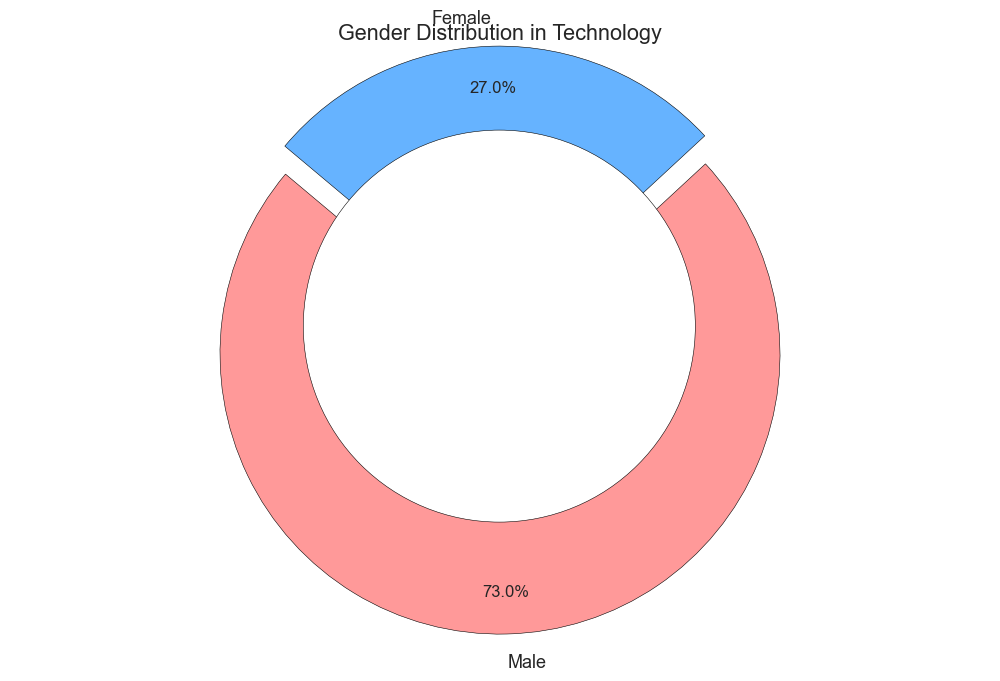What percentage of females are represented in Mathematics? The chart for Mathematics shows the distribution with clear labels for each gender. To find the percentage of females, refer to the labeled section for females.
Answer: 32% Which industry has the highest percentage of female representation? Look at all the pie charts and compare the labeled percentages for females across all industries to identify the highest value.
Answer: Science What is the combined percentage of males in both Engineering and Technology? Add the percentage of males in Engineering (85%) and Technology (73%).
Answer: 158% How much more percentage of males are there in Technology compared to females? Subtract the percentage of females in Technology (27%) from the percentage of males in Technology (73%).
Answer: 46% How does female representation in Science compare to that in Engineering? Compare the labeled female percentages in both Science (36%) and Engineering (15%).
Answer: Science has a higher female representation Which industry has the smallest gender gap? Calculate the gender gap for each industry by subtracting the female percentage from the male percentage and find the smallest value.
Answer: Science What is the difference in female representation between Science and Mathematics? Subtract the female percentage in Mathematics (32%) from the female percentage in Science (36%).
Answer: 4% If we were to average the percentage of female representation across all industries, what would it be? Add the percentage of females in each industry (27% in Technology, 15% in Engineering, 36% in Science, 32% in Mathematics) and divide by the number of industries (4).
Answer: 27.5% What percentage of males are represented in Science? The chart for Science shows the distribution with clear labels for each gender. To find the percentage of males, refer to the labeled section for males.
Answer: 64% In which industry is the gender disparity the greatest? Calculate the gender disparity for each industry by finding the difference between the male and female percentages, and identify the largest gap.
Answer: Engineering 